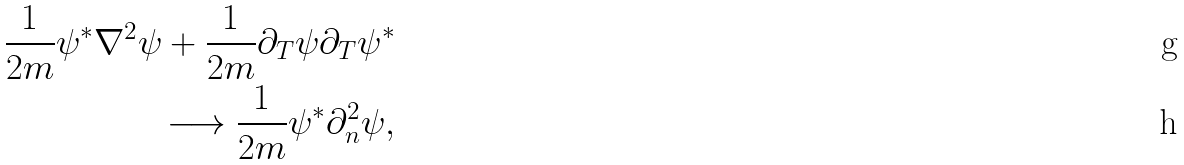<formula> <loc_0><loc_0><loc_500><loc_500>\frac { 1 } { 2 m } \psi ^ { * } { \nabla } ^ { 2 } \psi + \frac { 1 } { 2 m } { \partial } _ { T } \psi { \partial } _ { T } \psi ^ { * } \\ \longrightarrow \frac { 1 } { 2 m } \psi ^ { * } \partial _ { n } ^ { 2 } \psi ,</formula> 